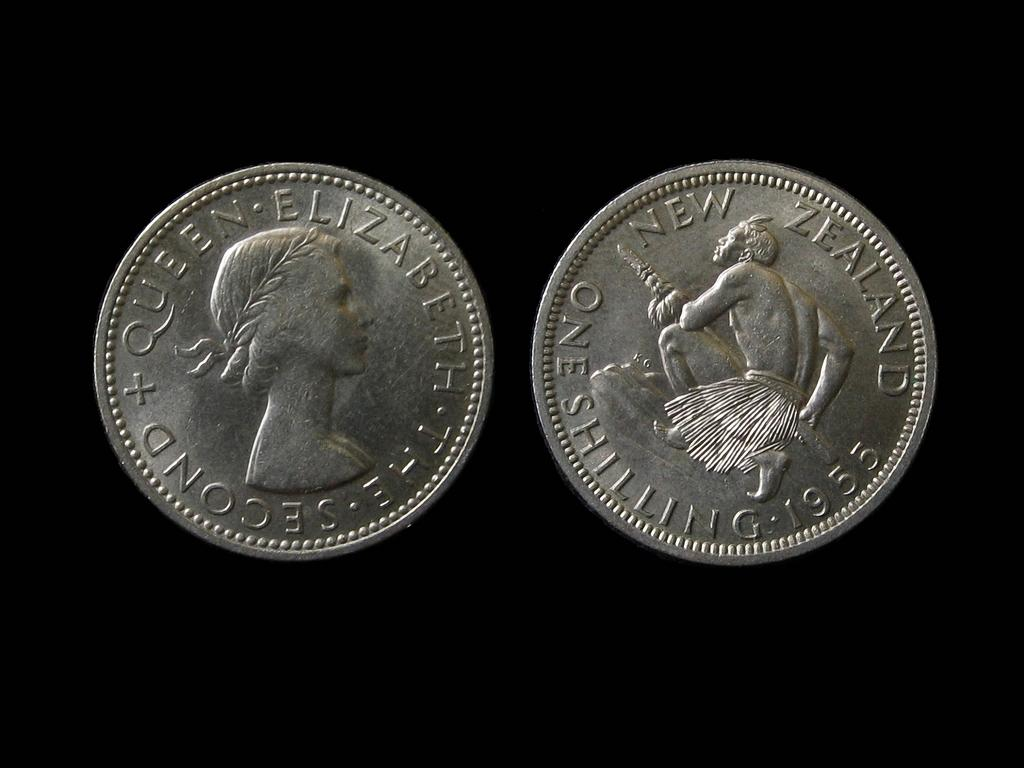Provide a one-sentence caption for the provided image. Two silver coins, one of which has the words Queen Elizabeth on it. 